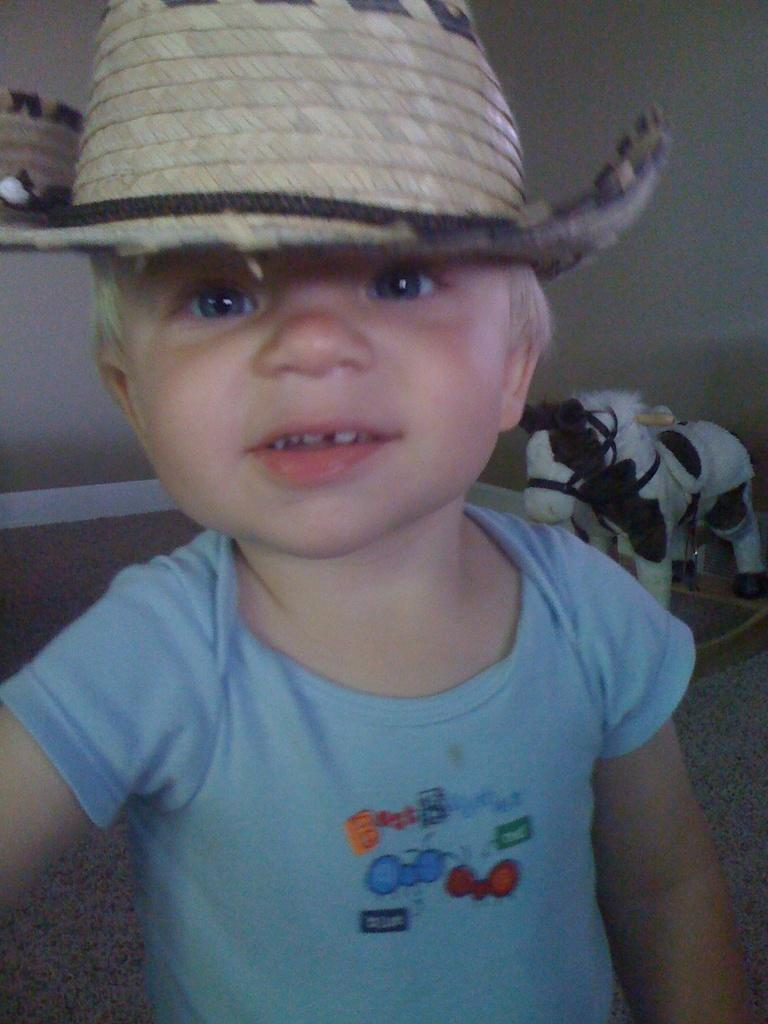What is the main subject of the image? There is a small baby in the image. What is the baby wearing on its head? The baby is wearing a hat. What object can be seen behind the baby? There is a toy behind the baby. Can you describe any furniture or structures in the image? There is a shelf in the image. What type of war is depicted in the image? There is no depiction of war in the image; it features a small baby wearing a hat and a toy behind the baby. What is the girl doing in the image? There is no girl present in the image; it features a small baby. 